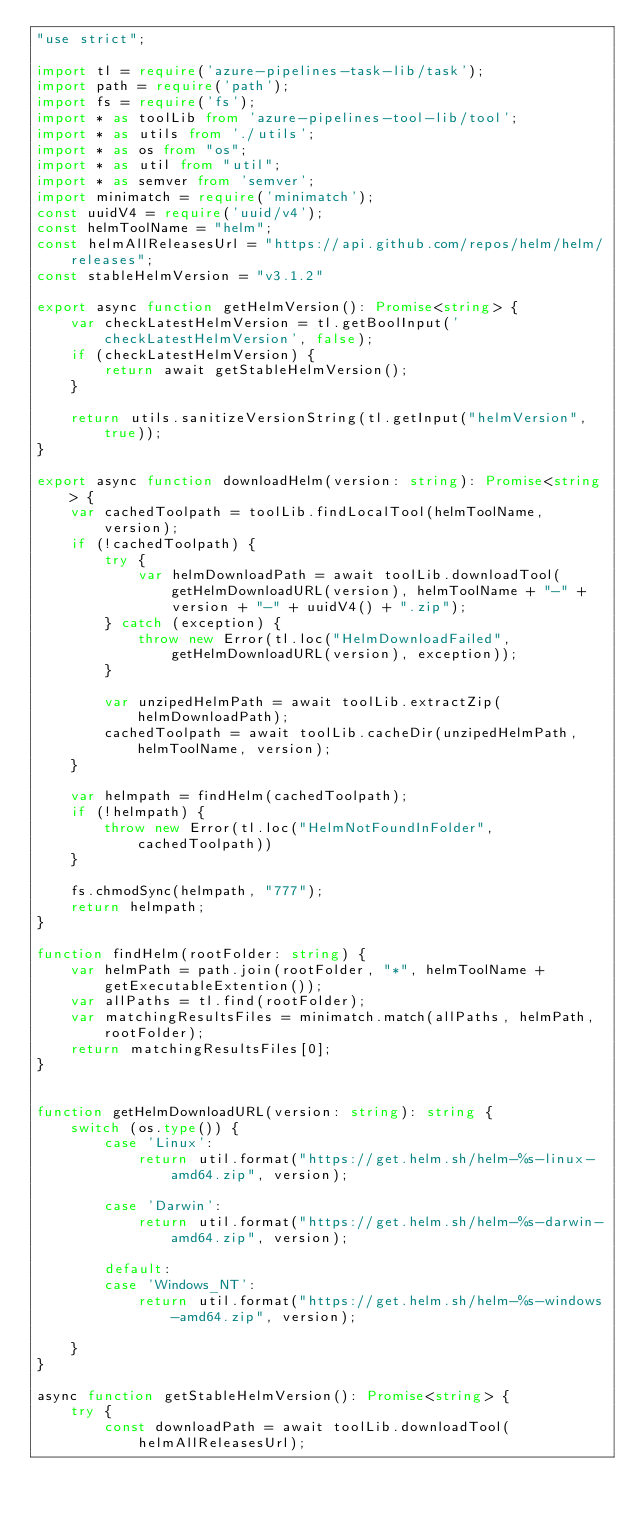<code> <loc_0><loc_0><loc_500><loc_500><_TypeScript_>"use strict";

import tl = require('azure-pipelines-task-lib/task');
import path = require('path');
import fs = require('fs');
import * as toolLib from 'azure-pipelines-tool-lib/tool';
import * as utils from './utils';
import * as os from "os";
import * as util from "util";
import * as semver from 'semver';
import minimatch = require('minimatch');
const uuidV4 = require('uuid/v4');
const helmToolName = "helm";
const helmAllReleasesUrl = "https://api.github.com/repos/helm/helm/releases";
const stableHelmVersion = "v3.1.2"

export async function getHelmVersion(): Promise<string> {
    var checkLatestHelmVersion = tl.getBoolInput('checkLatestHelmVersion', false);
    if (checkLatestHelmVersion) {
        return await getStableHelmVersion();
    }

    return utils.sanitizeVersionString(tl.getInput("helmVersion", true));
}

export async function downloadHelm(version: string): Promise<string> {
    var cachedToolpath = toolLib.findLocalTool(helmToolName, version);
    if (!cachedToolpath) {
        try {
            var helmDownloadPath = await toolLib.downloadTool(getHelmDownloadURL(version), helmToolName + "-" + version + "-" + uuidV4() + ".zip");
        } catch (exception) {
            throw new Error(tl.loc("HelmDownloadFailed", getHelmDownloadURL(version), exception));
        }

        var unzipedHelmPath = await toolLib.extractZip(helmDownloadPath);
        cachedToolpath = await toolLib.cacheDir(unzipedHelmPath, helmToolName, version);
    }

    var helmpath = findHelm(cachedToolpath);
    if (!helmpath) {
        throw new Error(tl.loc("HelmNotFoundInFolder", cachedToolpath))
    }

    fs.chmodSync(helmpath, "777");
    return helmpath;
}

function findHelm(rootFolder: string) {
    var helmPath = path.join(rootFolder, "*", helmToolName + getExecutableExtention());
    var allPaths = tl.find(rootFolder);
    var matchingResultsFiles = minimatch.match(allPaths, helmPath, rootFolder);
    return matchingResultsFiles[0];
}


function getHelmDownloadURL(version: string): string {
    switch (os.type()) {
        case 'Linux':
            return util.format("https://get.helm.sh/helm-%s-linux-amd64.zip", version);

        case 'Darwin':
            return util.format("https://get.helm.sh/helm-%s-darwin-amd64.zip", version);

        default:
        case 'Windows_NT':
            return util.format("https://get.helm.sh/helm-%s-windows-amd64.zip", version);

    }
}

async function getStableHelmVersion(): Promise<string> {
    try {
        const downloadPath = await toolLib.downloadTool(helmAllReleasesUrl);</code> 